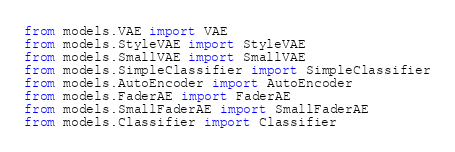Convert code to text. <code><loc_0><loc_0><loc_500><loc_500><_Python_>from models.VAE import VAE
from models.StyleVAE import StyleVAE
from models.SmallVAE import SmallVAE
from models.SimpleClassifier import SimpleClassifier
from models.AutoEncoder import AutoEncoder
from models.FaderAE import FaderAE
from models.SmallFaderAE import SmallFaderAE
from models.Classifier import Classifier</code> 